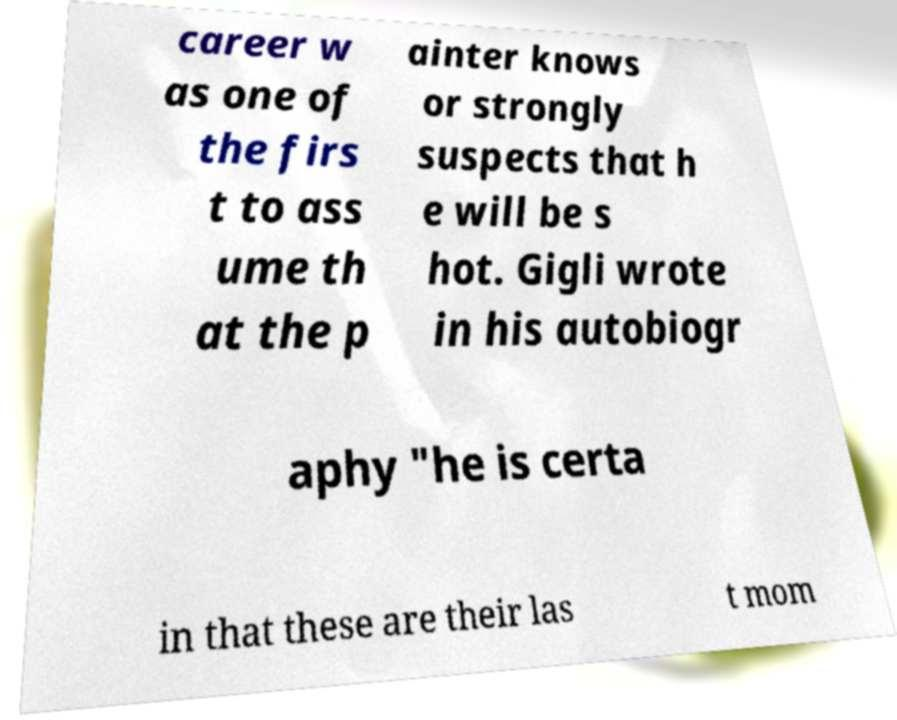Can you accurately transcribe the text from the provided image for me? career w as one of the firs t to ass ume th at the p ainter knows or strongly suspects that h e will be s hot. Gigli wrote in his autobiogr aphy "he is certa in that these are their las t mom 